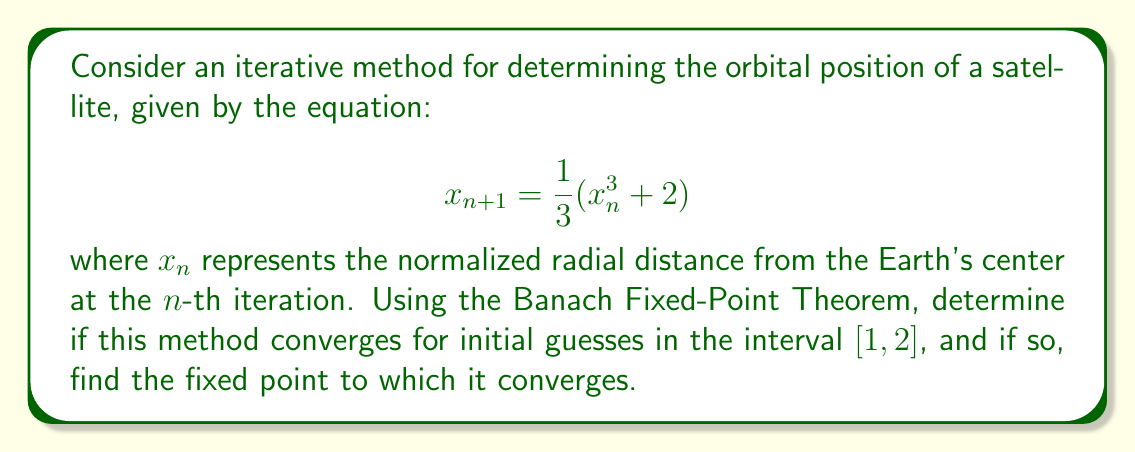Can you solve this math problem? To apply the Banach Fixed-Point Theorem, we need to show that the function $f(x) = \frac{1}{3}(x^3 + 2)$ is a contraction mapping on the interval $[1, 2]$.

Step 1: Check if $f$ maps $[1, 2]$ into itself.
For $x \in [1, 2]$:
$$1 \leq \frac{1}{3}(1^3 + 2) \leq f(x) \leq \frac{1}{3}(2^3 + 2) \leq 2$$
So, $f$ maps $[1, 2]$ into itself.

Step 2: Show that $f$ is a contraction mapping.
Calculate $f'(x) = x^2$
For $x \in [1, 2]$, $|f'(x)| \leq 4/3 < 1$

By the Mean Value Theorem, for any $x, y \in [1, 2]$:
$$|f(x) - f(y)| \leq \sup_{z \in [1,2]} |f'(z)| \cdot |x - y| \leq \frac{4}{3} |x - y|$$

This shows that $f$ is a contraction mapping with Lipschitz constant $L = 4/3$.

Step 3: Apply the Banach Fixed-Point Theorem.
Since $f$ is a contraction mapping on a closed interval, the theorem guarantees the existence of a unique fixed point in $[1, 2]$ to which the iteration will converge for any initial guess in this interval.

Step 4: Find the fixed point.
The fixed point satisfies $x = f(x)$:
$$x = \frac{1}{3}(x^3 + 2)$$
$$3x = x^3 + 2$$
$$x^3 - 3x + 2 = 0$$
$$(x - 1)(x^2 + x - 2) = 0$$
$$(x - 1)(x + 2)(x - 1) = 0$$

The only solution in $[1, 2]$ is $x = 1$.
Answer: The method converges to the fixed point $x = 1$ for all initial guesses in $[1, 2]$. 